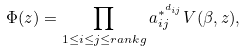Convert formula to latex. <formula><loc_0><loc_0><loc_500><loc_500>\Phi ( z ) = \prod _ { 1 \leq { i } \leq { j } \leq { r a n k g } } a _ { i j } ^ { * ^ { d _ { i j } } } V ( \beta , z ) ,</formula> 